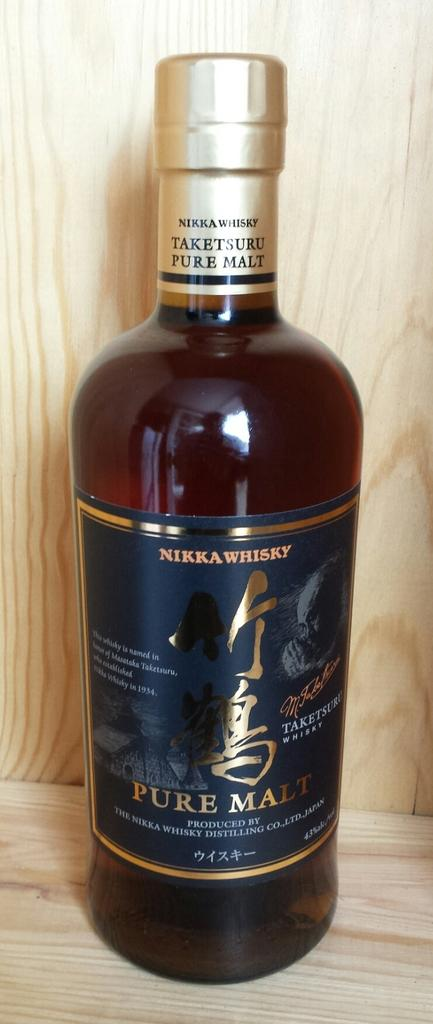<image>
Describe the image concisely. A bottle of Nikka whisky pure malt on a wooden table. 